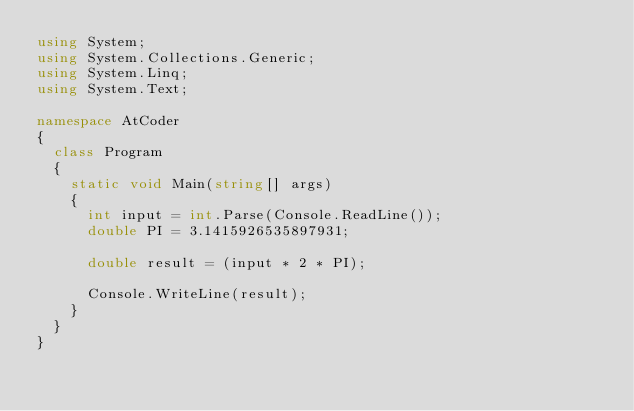<code> <loc_0><loc_0><loc_500><loc_500><_C#_>using System;
using System.Collections.Generic;
using System.Linq;
using System.Text;

namespace AtCoder
{
  class Program
  {
    static void Main(string[] args)
    {
      int input = int.Parse(Console.ReadLine());
      double PI = 3.1415926535897931;
      
      double result = (input * 2 * PI);
      
      Console.WriteLine(result);
    }
  }
}</code> 